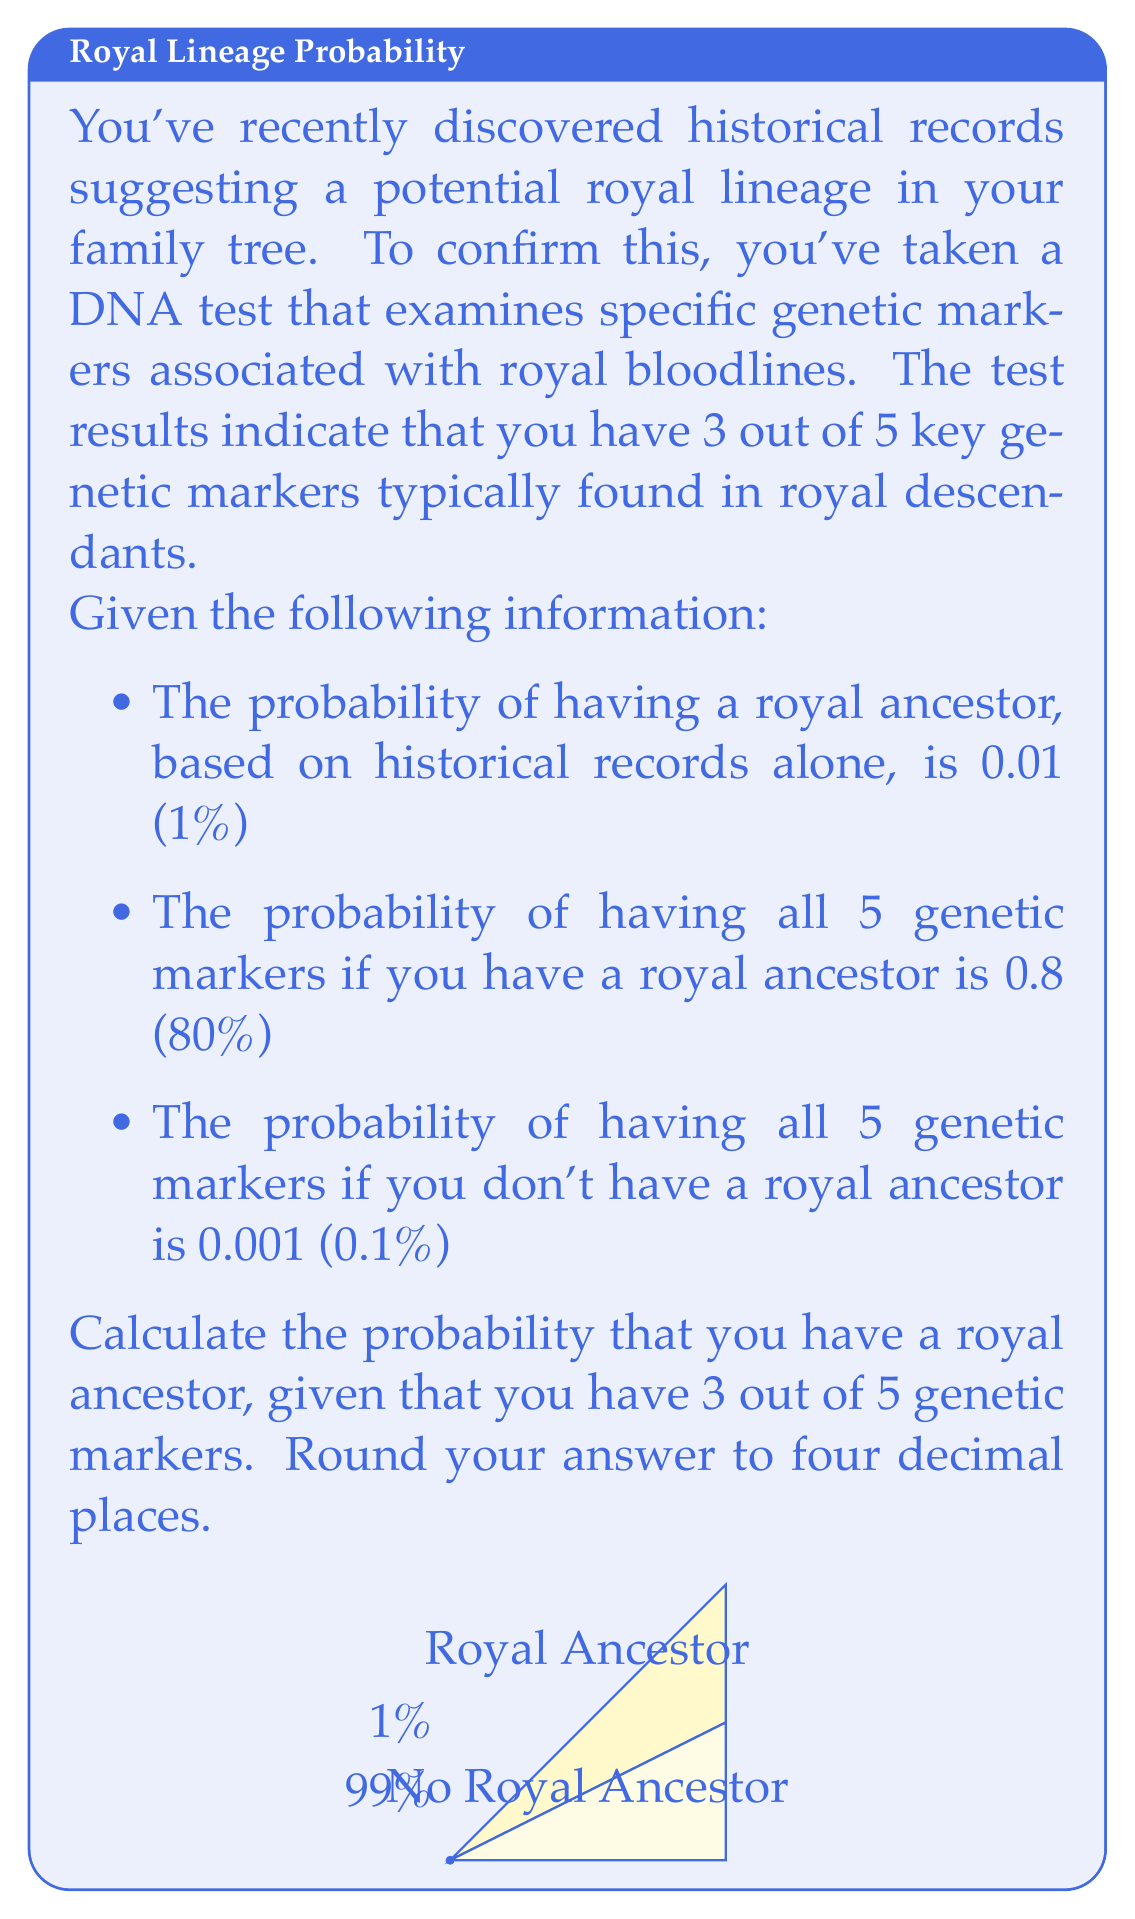Provide a solution to this math problem. Let's approach this problem using Bayes' Theorem. We'll denote:
R: Having a royal ancestor
M: Having 3 out of 5 genetic markers

1) First, we need to calculate $P(M|R)$ and $P(M|\text{not }R)$:

   $P(M|R) = \binom{5}{3}(0.8)^3(0.2)^2 = 0.2048$
   $P(M|\text{not }R) = \binom{5}{3}(0.001)^3(0.999)^2 = 9.97 \times 10^{-9}$

2) Now we can apply Bayes' Theorem:

   $$P(R|M) = \frac{P(M|R)P(R)}{P(M|R)P(R) + P(M|\text{not }R)P(\text{not }R)}$$

3) Substituting the values:

   $$P(R|M) = \frac{0.2048 \times 0.01}{0.2048 \times 0.01 + 9.97 \times 10^{-9} \times 0.99}$$

4) Calculating:

   $$P(R|M) = \frac{0.002048}{0.002048 + 9.8703 \times 10^{-9}} = 0.9999952$$

5) Rounding to four decimal places:

   $$P(R|M) \approx 1.0000$$
Answer: $1.0000$ 